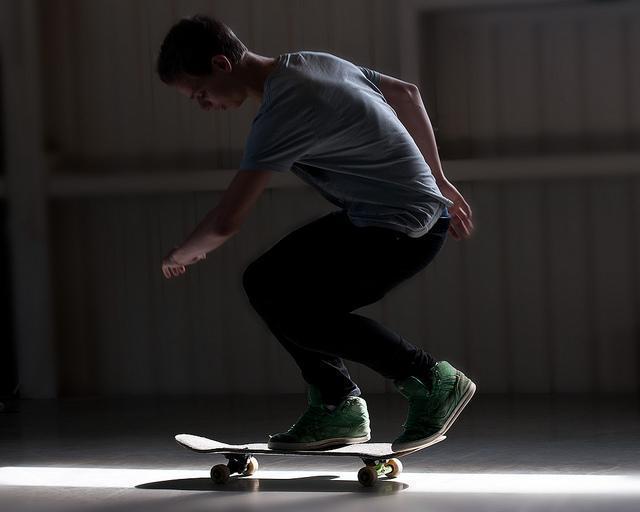How many of the airplanes have entrails?
Give a very brief answer. 0. 